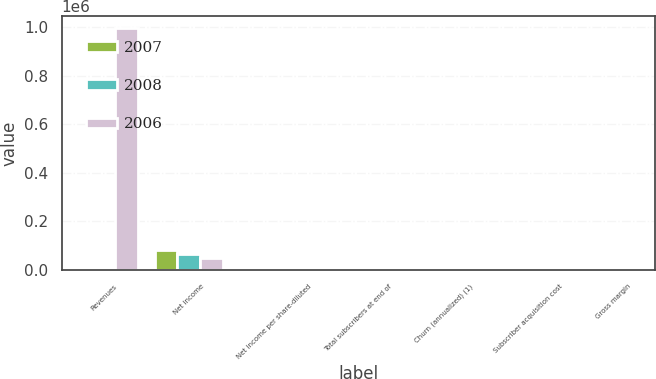<chart> <loc_0><loc_0><loc_500><loc_500><stacked_bar_chart><ecel><fcel>Revenues<fcel>Net income<fcel>Net income per share-diluted<fcel>Total subscribers at end of<fcel>Churn (annualized) (1)<fcel>Subscriber acquisition cost<fcel>Gross margin<nl><fcel>2007<fcel>37.1<fcel>83026<fcel>1.32<fcel>9390<fcel>4.2<fcel>29.12<fcel>33.3<nl><fcel>2008<fcel>37.1<fcel>66608<fcel>0.97<fcel>7479<fcel>4.3<fcel>40.86<fcel>34.8<nl><fcel>2006<fcel>996660<fcel>48839<fcel>0.71<fcel>6316<fcel>4.1<fcel>42.94<fcel>37.1<nl></chart> 